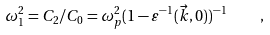<formula> <loc_0><loc_0><loc_500><loc_500>\omega ^ { 2 } _ { 1 } = C _ { 2 } / C _ { 0 } = \omega ^ { 2 } _ { p } ( 1 - \varepsilon ^ { - 1 } ( \vec { k } , 0 ) ) ^ { - 1 } \quad ,</formula> 